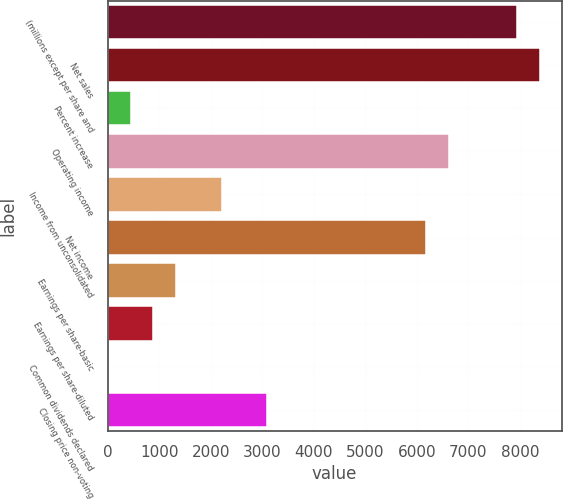<chart> <loc_0><loc_0><loc_500><loc_500><bar_chart><fcel>(millions except per share and<fcel>Net sales<fcel>Percent increase<fcel>Operating income<fcel>Income from unconsolidated<fcel>Net income<fcel>Earnings per share-basic<fcel>Earnings per share-diluted<fcel>Common dividends declared<fcel>Closing price non-voting<nl><fcel>7947.67<fcel>8389.13<fcel>442.85<fcel>6623.29<fcel>2208.69<fcel>6181.83<fcel>1325.77<fcel>884.31<fcel>1.39<fcel>3091.61<nl></chart> 